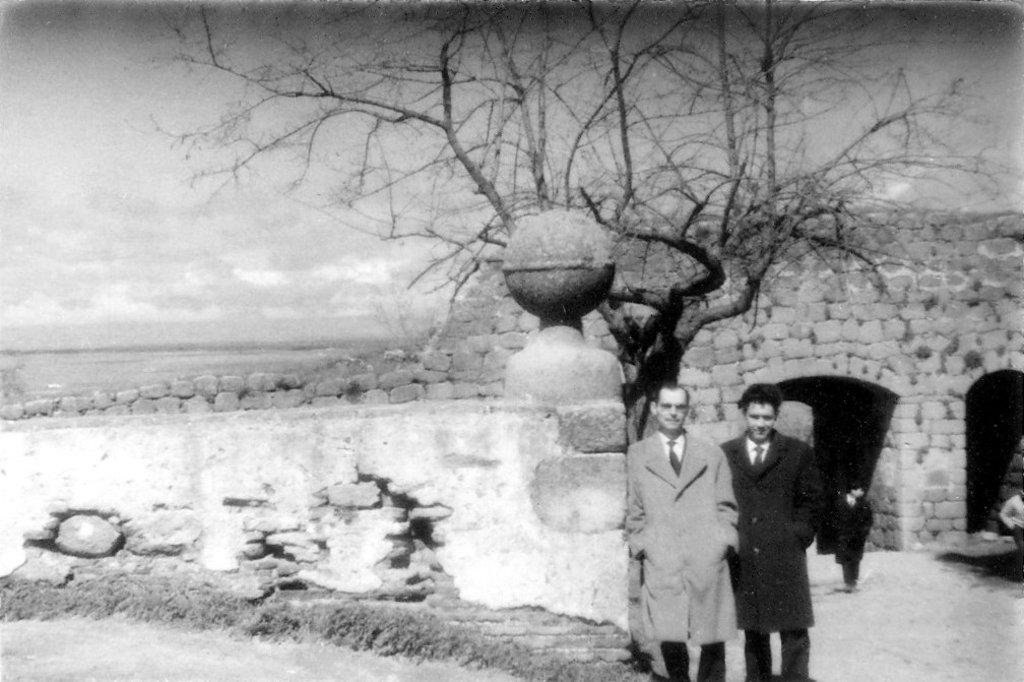How many people are in the image? There are two persons standing in the image. What can be seen in the background of the image? There is a wall and a dried tree in the background of the image. What is visible in the sky in the image? The sky is visible in the background of the image. What is the color scheme of the image? The image is in black and white. How many tomatoes are on the son's plate in the image? There is no son or plate with tomatoes present in the image. What type of afterthought is depicted in the image? There is no afterthought depicted in the image; it features two people standing in front of a wall and a dried tree. 